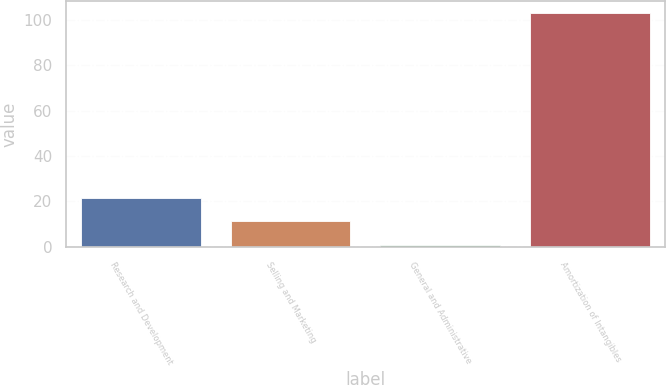Convert chart to OTSL. <chart><loc_0><loc_0><loc_500><loc_500><bar_chart><fcel>Research and Development<fcel>Selling and Marketing<fcel>General and Administrative<fcel>Amortization of Intangibles<nl><fcel>21.4<fcel>11.2<fcel>1<fcel>103<nl></chart> 